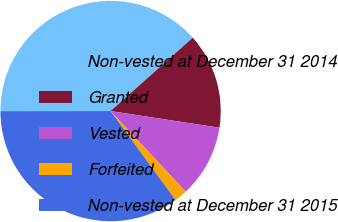<chart> <loc_0><loc_0><loc_500><loc_500><pie_chart><fcel>Non-vested at December 31 2014<fcel>Granted<fcel>Vested<fcel>Forfeited<fcel>Non-vested at December 31 2015<nl><fcel>38.41%<fcel>14.02%<fcel>10.64%<fcel>1.9%<fcel>35.02%<nl></chart> 